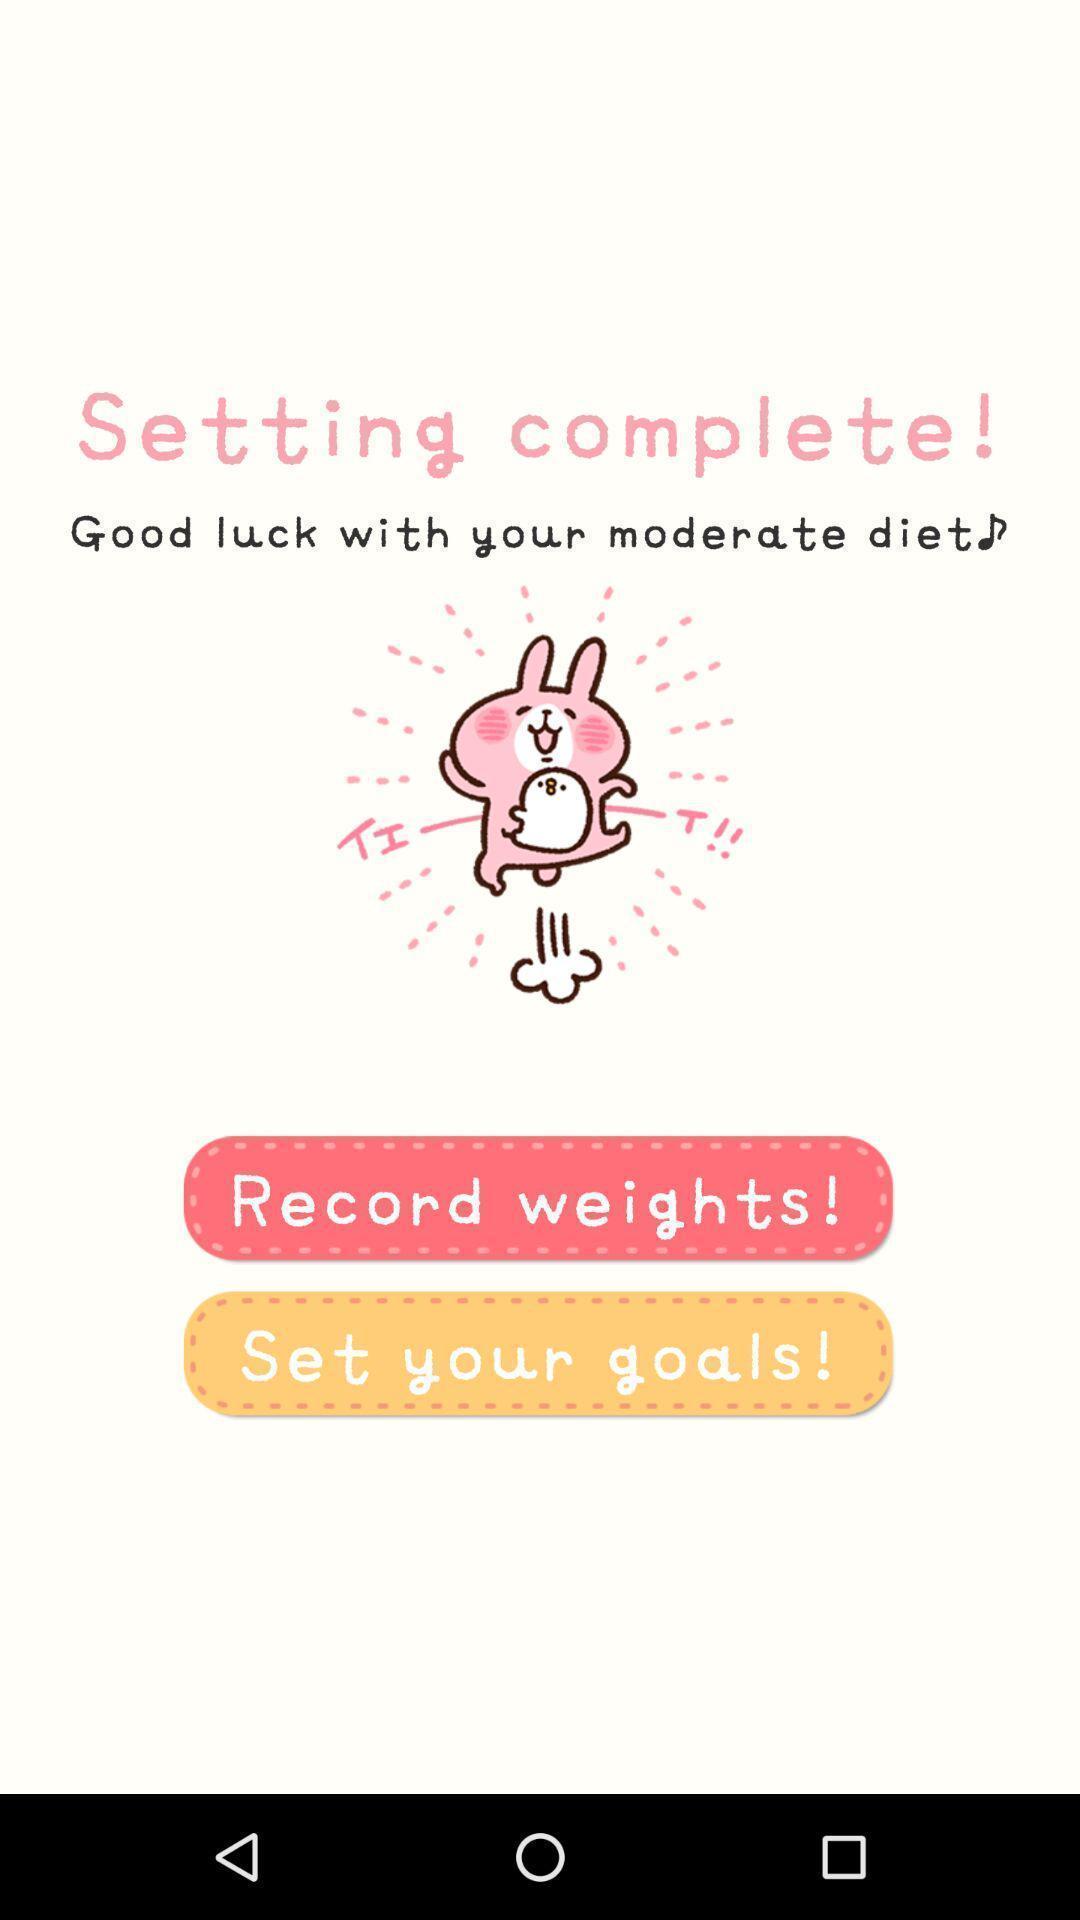Summarize the main components in this picture. Page with set your goals option. 